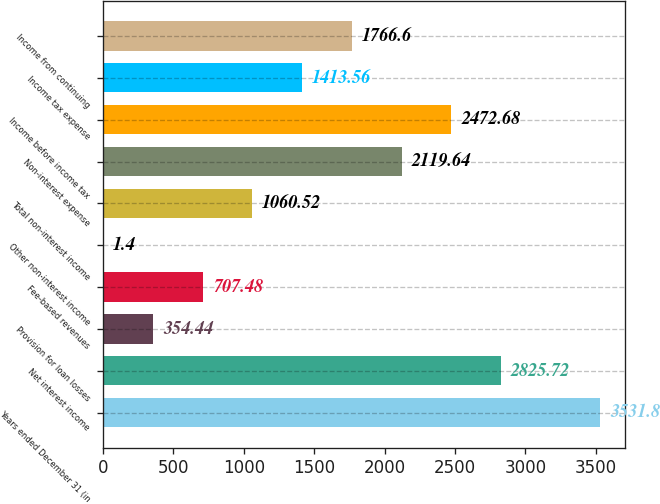<chart> <loc_0><loc_0><loc_500><loc_500><bar_chart><fcel>Years ended December 31 (in<fcel>Net interest income<fcel>Provision for loan losses<fcel>Fee-based revenues<fcel>Other non-interest income<fcel>Total non-interest income<fcel>Non-interest expense<fcel>Income before income tax<fcel>Income tax expense<fcel>Income from continuing<nl><fcel>3531.8<fcel>2825.72<fcel>354.44<fcel>707.48<fcel>1.4<fcel>1060.52<fcel>2119.64<fcel>2472.68<fcel>1413.56<fcel>1766.6<nl></chart> 